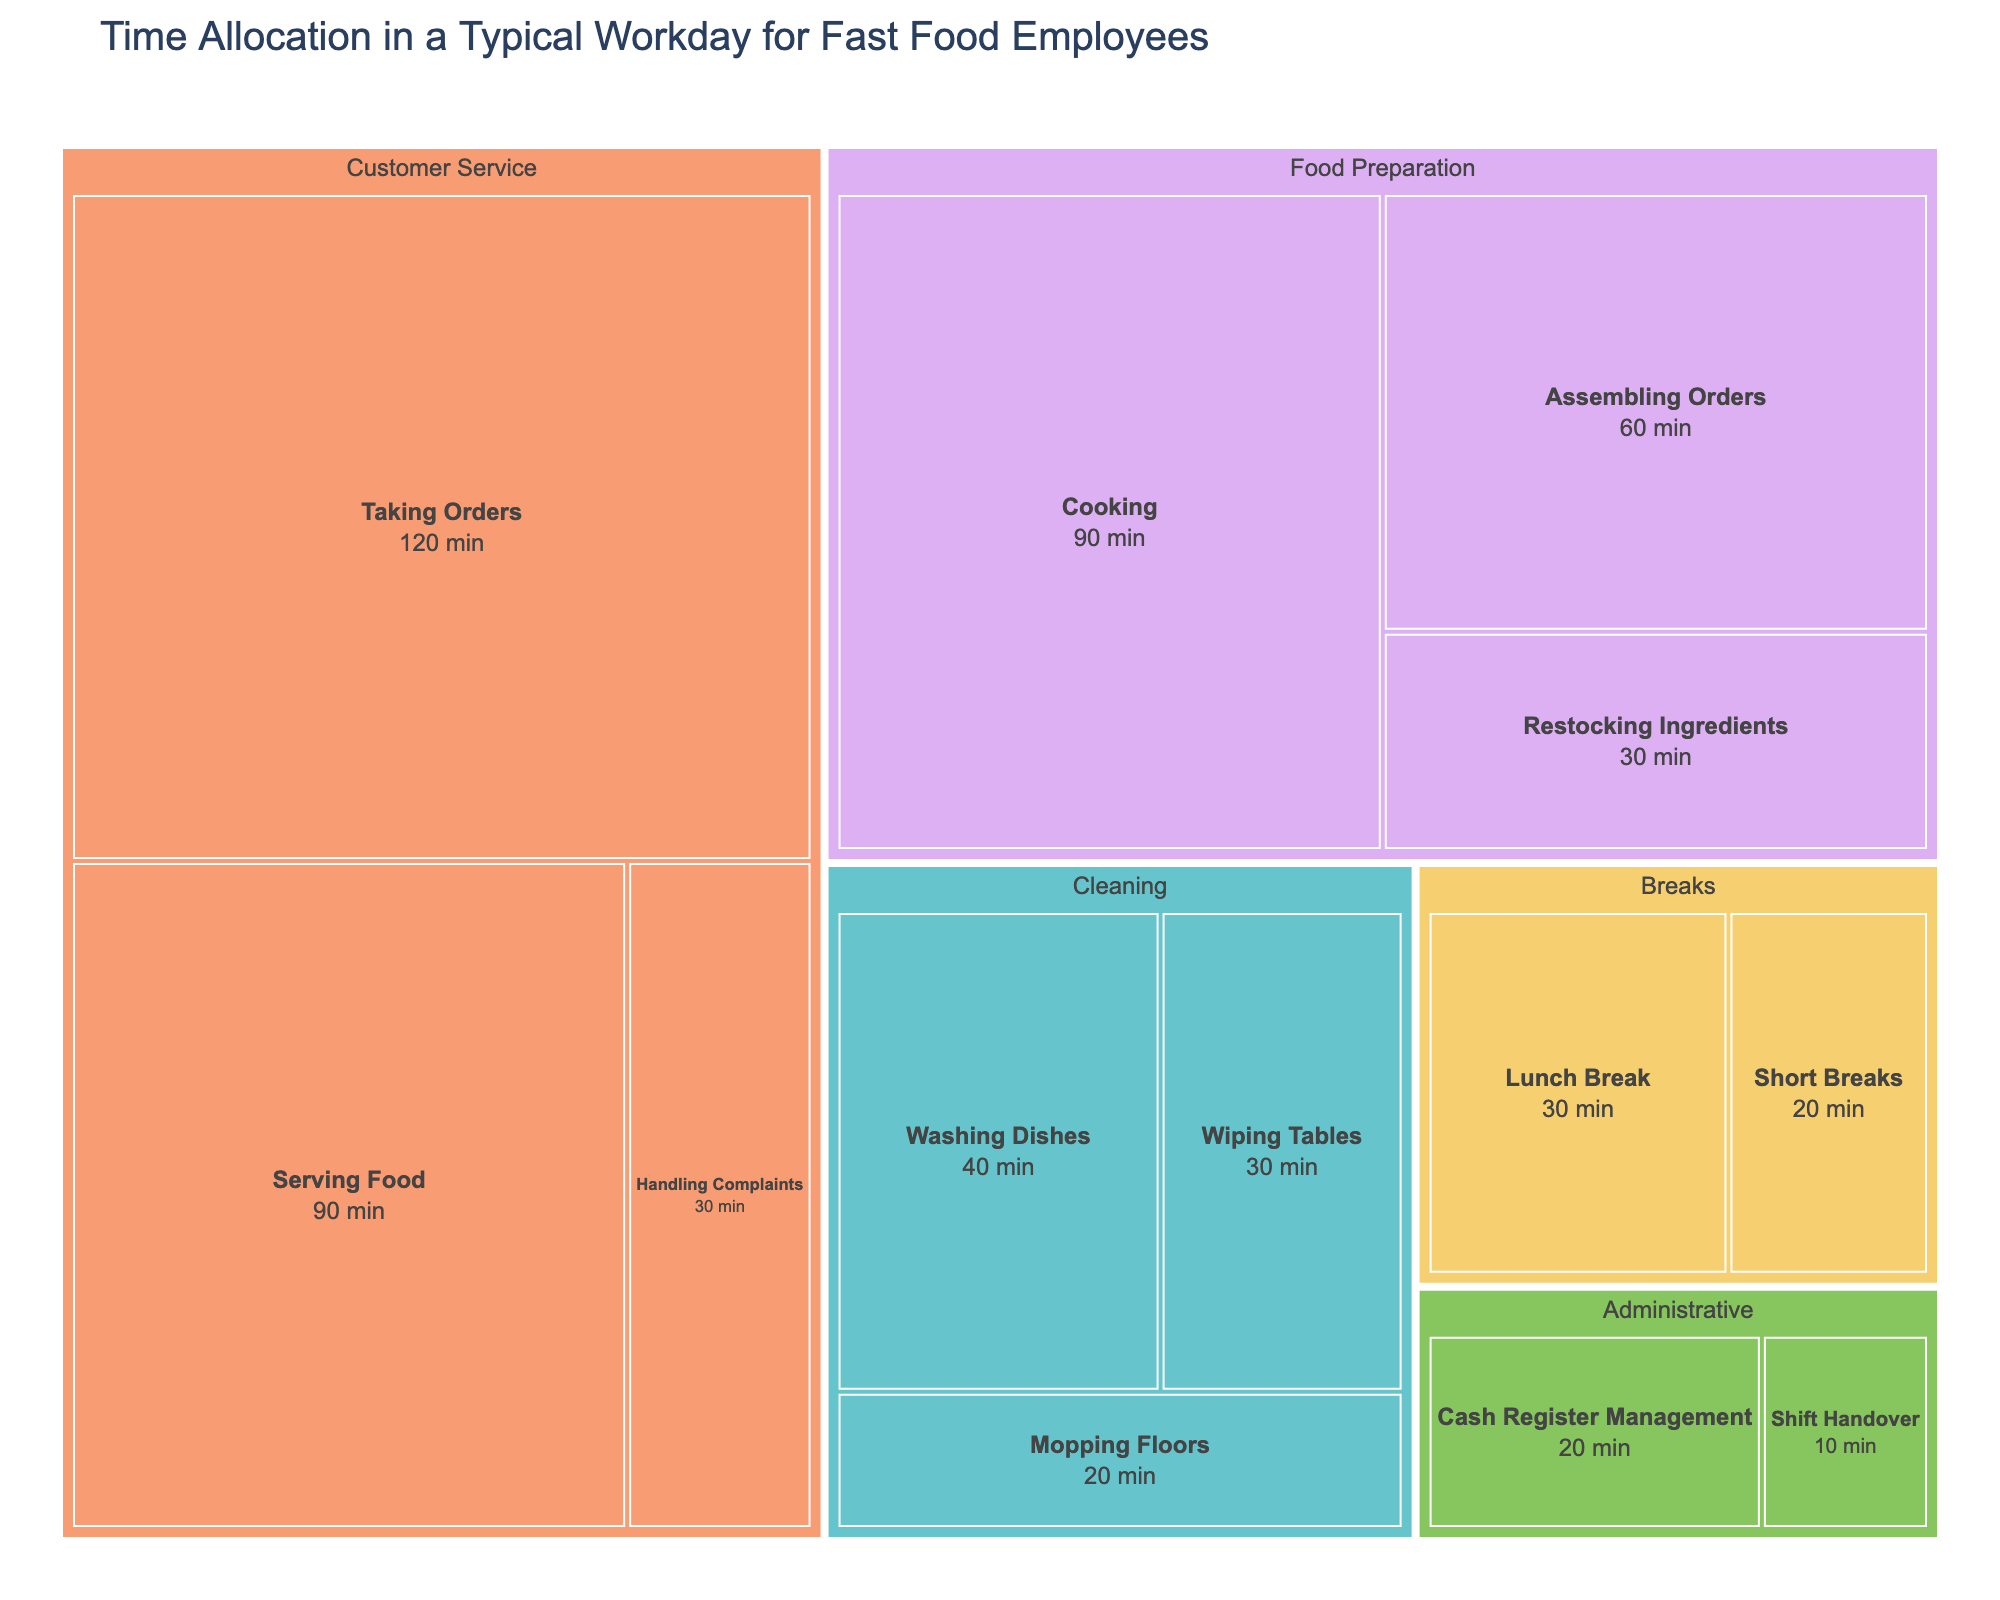What is the title of the treemap? The title of the treemap is usually prominently displayed at the top of the figure. In this case, according to the provided code, the title is "Time Allocation in a Typical Workday for Fast Food Employees".
Answer: Time Allocation in a Typical Workday for Fast Food Employees Which subcategory has the highest time allocation? To find the subcategory with the highest time allocation, look for the largest block within the treemap. "Taking Orders" under the "Customer Service" category has the highest time allocation of 120 minutes.
Answer: Taking Orders How much total time is spent on Customer Service activities? Add up the time for each subcategory under "Customer Service": "Taking Orders" (120 minutes), "Serving Food" (90 minutes), and "Handling Complaints" (30 minutes). The total is 120 + 90 + 30 = 240 minutes.
Answer: 240 minutes Which category has the smallest time allocation and what is the subcategory? Identify the smallest block within the treemap, which represents the minimum time allocation. The smallest category is "Administrative" with the subcategory "Shift Handover" having 10 minutes.
Answer: Administrative, Shift Handover Is more or less time spent on Cleaning compared to Food Preparation? Summarize the time spent on Cleaning ("Wiping Tables" 30 minutes, "Mopping Floors" 20 minutes, "Washing Dishes" 40 minutes) versus Food Preparation ("Cooking" 90 minutes, "Assembling Orders" 60 minutes, "Restocking Ingredients" 30 minutes). Cleaning total: 30 + 20 + 40 = 90 minutes. Food Preparation total: 90 + 60 + 30 = 180 minutes. Cleaning has less time allocated.
Answer: less What is the average time spent on Breaks? There are two subcategories under Breaks: "Lunch Break" (30 minutes) and "Short Breaks" (20 minutes). The average is (30 + 20) / 2 = 25 minutes.
Answer: 25 minutes Which activity within Food Preparation takes the most time? Review the subcategories under "Food Preparation" and identify the highest value. "Cooking" with 90 minutes takes the most time.
Answer: Cooking How does the time spent on Serving Food compare to the time spent on Washing Dishes? Compare the time allocation for "Serving Food" (90 minutes) and "Washing Dishes" (40 minutes). Serving Food takes more time than Washing Dishes.
Answer: more What is the total time allocated for Administrative tasks? Add the time for each subcategory under "Administrative": "Cash Register Management" (20 minutes) and "Shift Handover" (10 minutes). The total is 20 + 10 = 30 minutes.
Answer: 30 minutes In which category is the subcategory with the least time allocation found? Locate the smallest subcategory in the treemap, which is "Shift Handover" with 10 minutes. This subcategory is under the "Administrative" category.
Answer: Administrative 